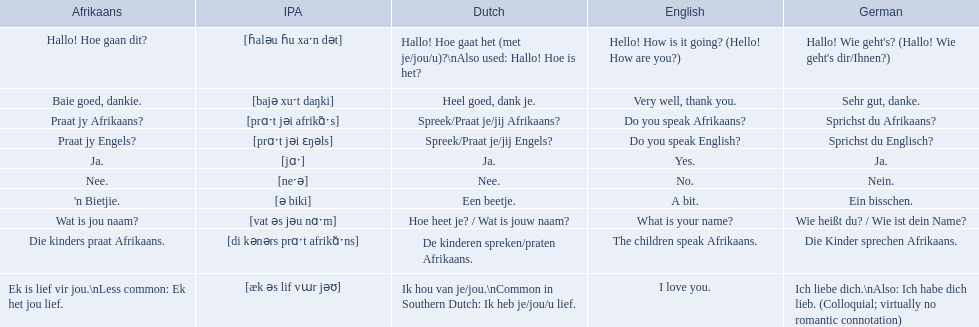Which expressions are used in afrikaans? Hallo! Hoe gaan dit?, Baie goed, dankie., Praat jy Afrikaans?, Praat jy Engels?, Ja., Nee., 'n Bietjie., Wat is jou naam?, Die kinders praat Afrikaans., Ek is lief vir jou.\nLess common: Ek het jou lief. Which of these signify how to speak afrikaans? Praat jy Afrikaans?. 